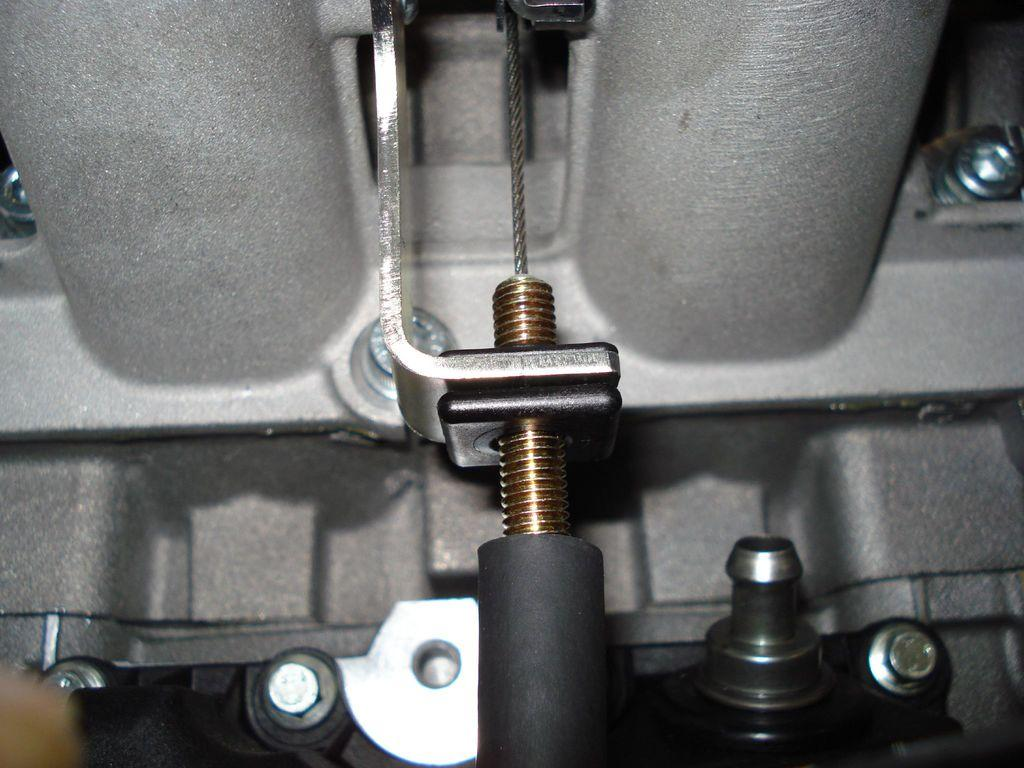What type of food is present in the image? There are nuts in the image. What feature can be seen in the image that might suggest a passage or opening? There is a hole in the image. What type of man-made objects can be seen in the image? There are pipes in the image. What type of skirt is hanging on the wall in the image? There is no skirt present in the image; it only contains nuts, a hole, and pipes. 